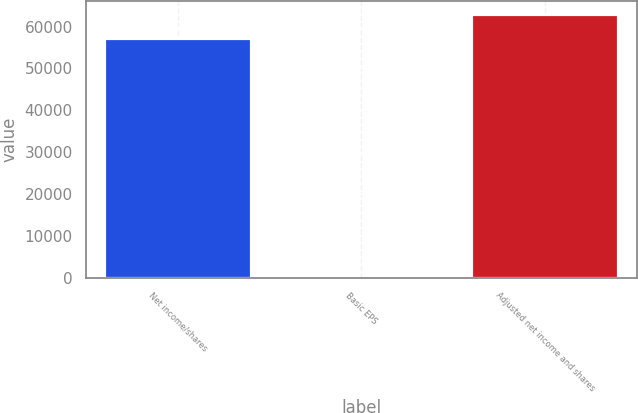Convert chart to OTSL. <chart><loc_0><loc_0><loc_500><loc_500><bar_chart><fcel>Net income/shares<fcel>Basic EPS<fcel>Adjusted net income and shares<nl><fcel>57196<fcel>0.31<fcel>62972.3<nl></chart> 